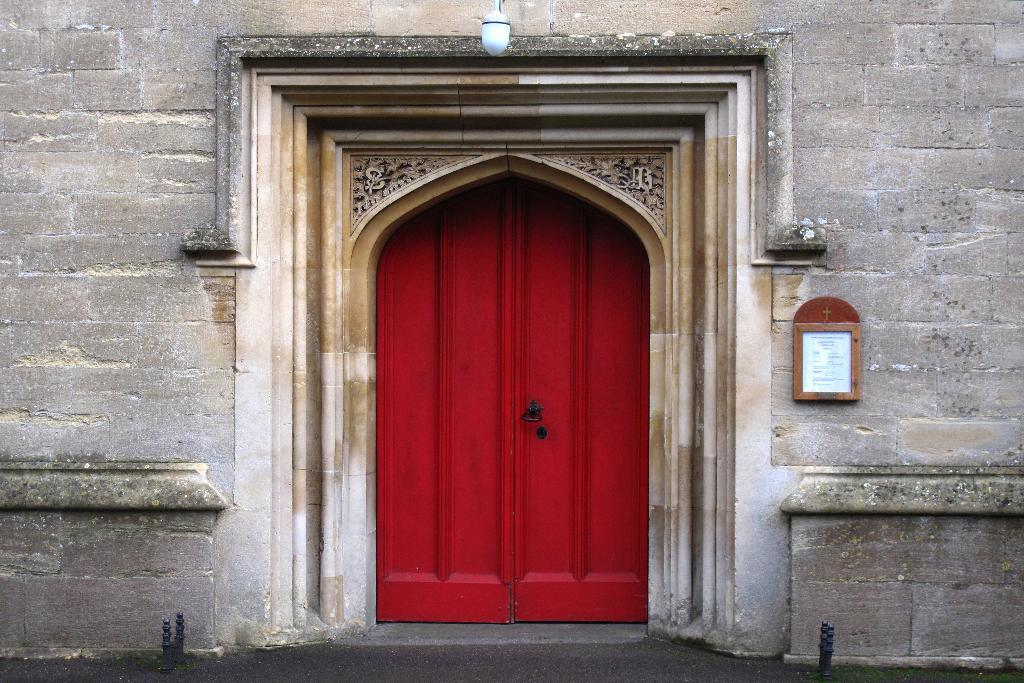What structure is visible in the image? There is a door in the image. What is attached to the wall in the image? There is a board attached to the wall in the image. What type of vertical structures are present in the image? There are poles in the image. What type of surface can be seen in the image? There is a road in the image. Can you see the comfort of the sea in the image? There is no sea or any reference to comfort in the image. Is there a church visible in the image? There is no church present in the image. 